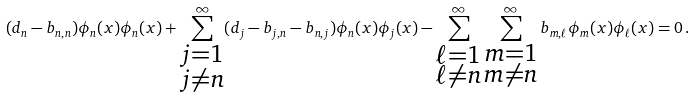<formula> <loc_0><loc_0><loc_500><loc_500>( d _ { n } - b _ { n , n } ) \phi _ { n } ( x ) \phi _ { n } ( x ) + \sum _ { \substack { j = 1 \\ j \neq n } } ^ { \infty } ( d _ { j } - b _ { j , n } - b _ { n , j } ) \phi _ { n } ( x ) \phi _ { j } ( x ) - \sum _ { \substack { \ell = 1 \\ \ell \neq n } } ^ { \infty } \sum _ { \substack { m = 1 \\ m \neq n } } ^ { \infty } b _ { m , \ell } \phi _ { m } ( x ) \phi _ { \ell } ( x ) = 0 \, .</formula> 